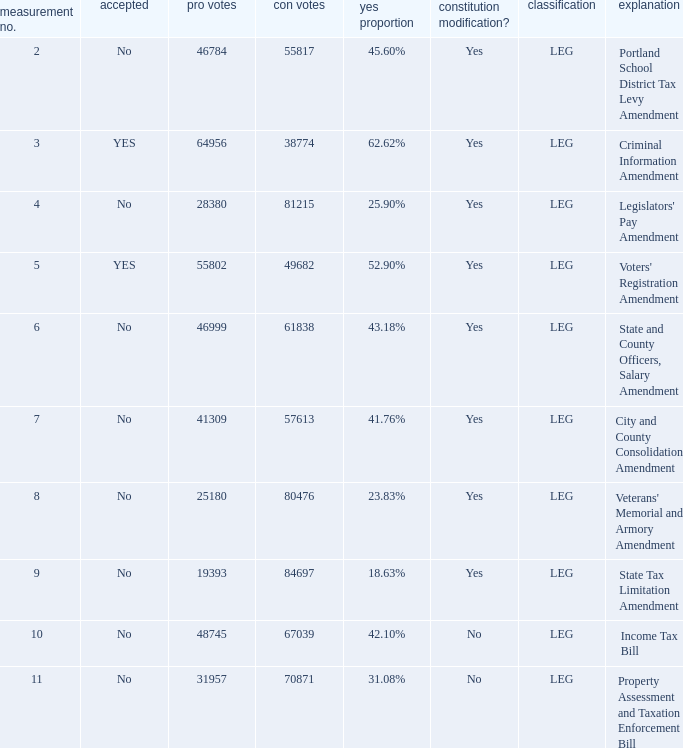Could you help me parse every detail presented in this table? {'header': ['measurement no.', 'accepted', 'pro votes', 'con votes', 'yes proportion', 'constitution modification?', 'classification', 'explanation'], 'rows': [['2', 'No', '46784', '55817', '45.60%', 'Yes', 'LEG', 'Portland School District Tax Levy Amendment'], ['3', 'YES', '64956', '38774', '62.62%', 'Yes', 'LEG', 'Criminal Information Amendment'], ['4', 'No', '28380', '81215', '25.90%', 'Yes', 'LEG', "Legislators' Pay Amendment"], ['5', 'YES', '55802', '49682', '52.90%', 'Yes', 'LEG', "Voters' Registration Amendment"], ['6', 'No', '46999', '61838', '43.18%', 'Yes', 'LEG', 'State and County Officers, Salary Amendment'], ['7', 'No', '41309', '57613', '41.76%', 'Yes', 'LEG', 'City and County Consolidation Amendment'], ['8', 'No', '25180', '80476', '23.83%', 'Yes', 'LEG', "Veterans' Memorial and Armory Amendment"], ['9', 'No', '19393', '84697', '18.63%', 'Yes', 'LEG', 'State Tax Limitation Amendment'], ['10', 'No', '48745', '67039', '42.10%', 'No', 'LEG', 'Income Tax Bill'], ['11', 'No', '31957', '70871', '31.08%', 'No', 'LEG', 'Property Assessment and Taxation Enforcement Bill']]} Who had 41.76% yes votes City and County Consolidation Amendment. 